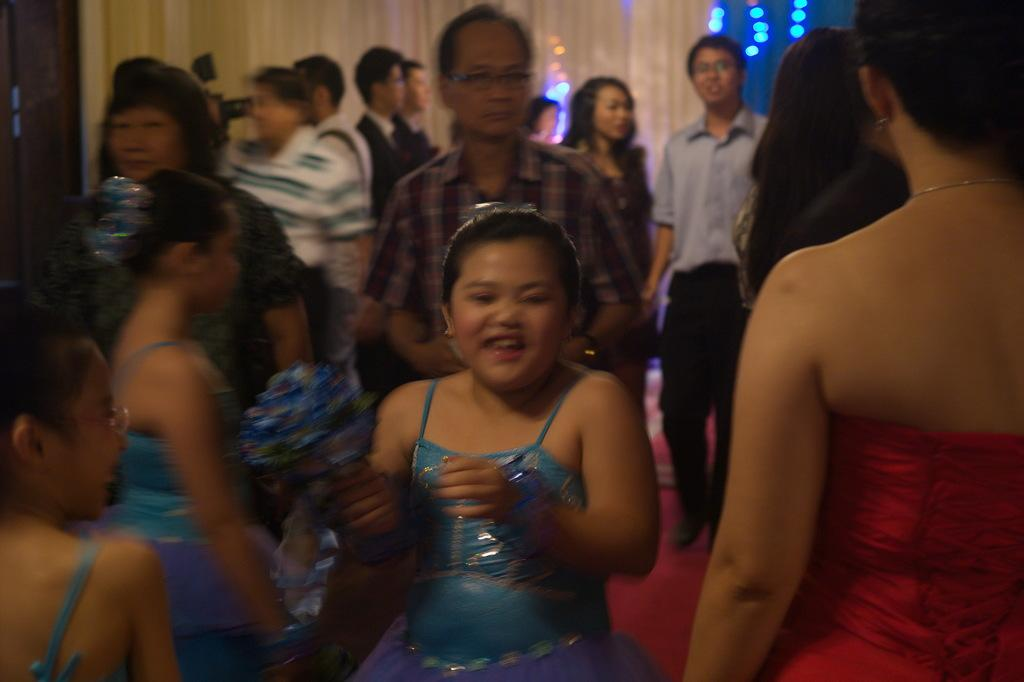What can be seen in the image? There are people standing in the image, including a girl in the front. What is the condition of the girl in the image? The girl is smiling in the image. What can be seen in the background of the image? There are lights and curtains in the background of the image. What type of garden can be seen in the image? There is no garden present in the image. How does the ray of light affect the girl's appearance in the image? There is no ray of light mentioned in the image, so its effect on the girl's appearance cannot be determined. 